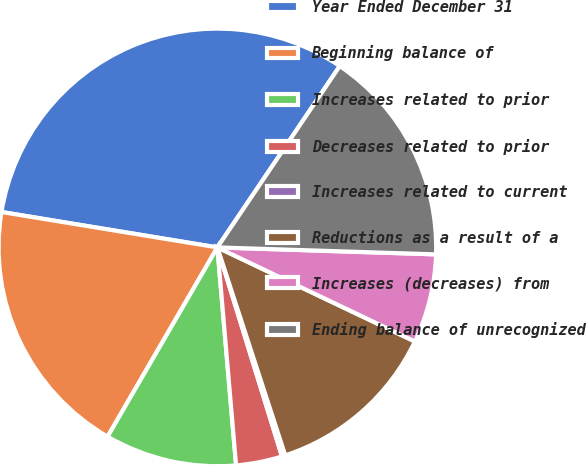<chart> <loc_0><loc_0><loc_500><loc_500><pie_chart><fcel>Year Ended December 31<fcel>Beginning balance of<fcel>Increases related to prior<fcel>Decreases related to prior<fcel>Increases related to current<fcel>Reductions as a result of a<fcel>Increases (decreases) from<fcel>Ending balance of unrecognized<nl><fcel>31.86%<fcel>19.22%<fcel>9.73%<fcel>3.41%<fcel>0.25%<fcel>12.9%<fcel>6.57%<fcel>16.06%<nl></chart> 